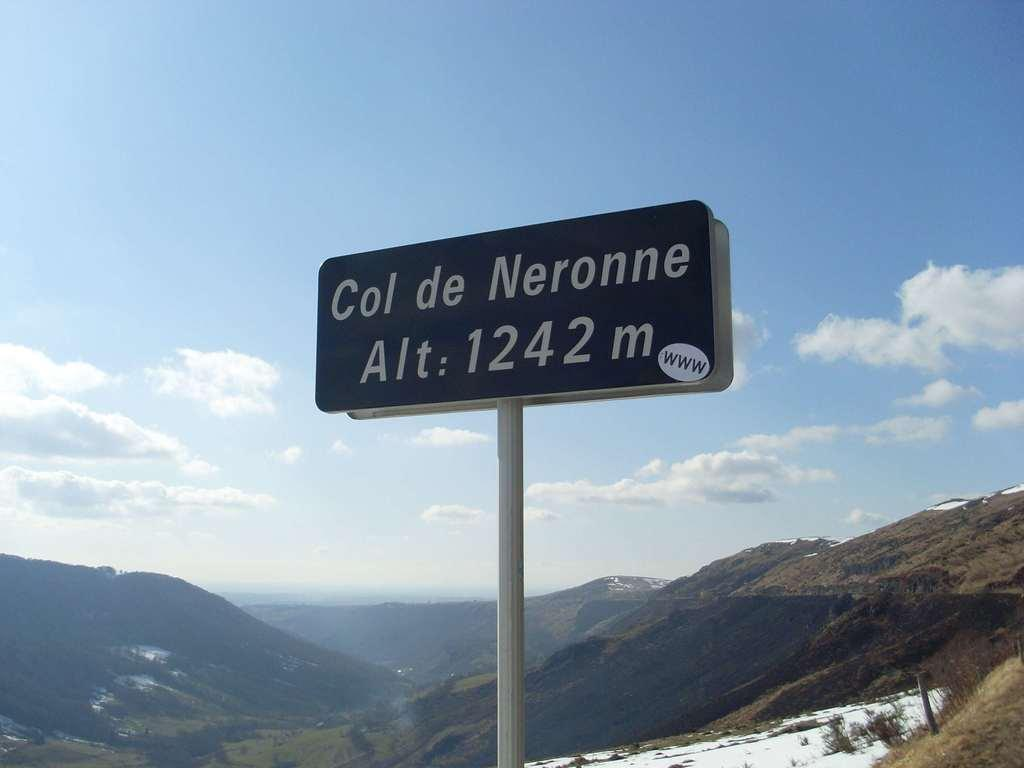<image>
Relay a brief, clear account of the picture shown. the word col that is on a green sign 